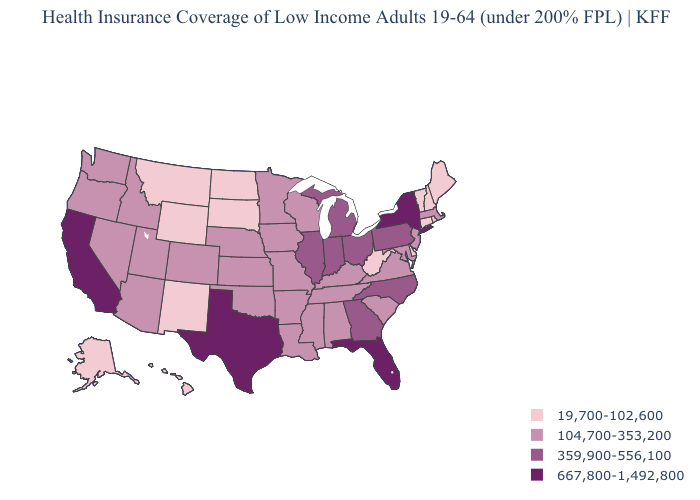Which states have the highest value in the USA?
Concise answer only. California, Florida, New York, Texas. Which states hav the highest value in the West?
Give a very brief answer. California. What is the highest value in the Northeast ?
Quick response, please. 667,800-1,492,800. Name the states that have a value in the range 359,900-556,100?
Be succinct. Georgia, Illinois, Indiana, Michigan, North Carolina, Ohio, Pennsylvania. What is the value of North Carolina?
Give a very brief answer. 359,900-556,100. What is the lowest value in the South?
Keep it brief. 19,700-102,600. Which states have the highest value in the USA?
Be succinct. California, Florida, New York, Texas. Name the states that have a value in the range 667,800-1,492,800?
Concise answer only. California, Florida, New York, Texas. Among the states that border Illinois , does Missouri have the lowest value?
Answer briefly. Yes. Is the legend a continuous bar?
Concise answer only. No. Name the states that have a value in the range 19,700-102,600?
Keep it brief. Alaska, Connecticut, Delaware, Hawaii, Maine, Montana, New Hampshire, New Mexico, North Dakota, Rhode Island, South Dakota, Vermont, West Virginia, Wyoming. Does California have the lowest value in the USA?
Give a very brief answer. No. Among the states that border Nevada , which have the highest value?
Short answer required. California. Is the legend a continuous bar?
Answer briefly. No. Which states hav the highest value in the West?
Write a very short answer. California. 